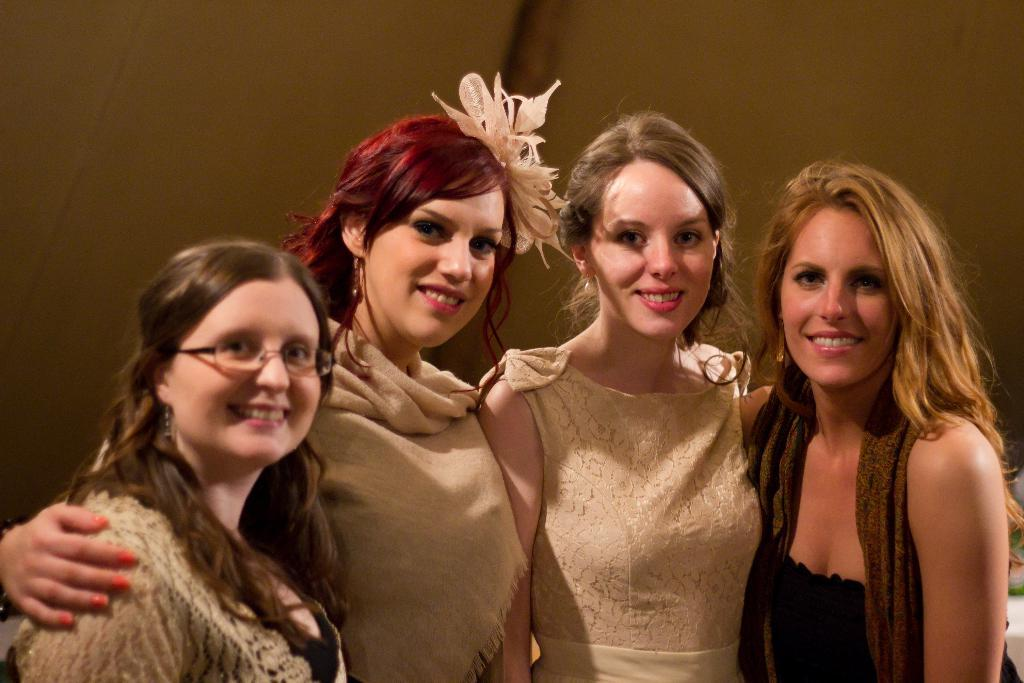What can be seen in the image? There are women standing in the image. What are the women wearing? The women are wearing clothes. What is present in the background of the image? There is a wall in the image. What type of quince is being used as a prop in the image? There is no quince present in the image. What stitch is being used to create the clothing the women are wearing? The provided facts do not mention any specific stitch used in the clothing. 